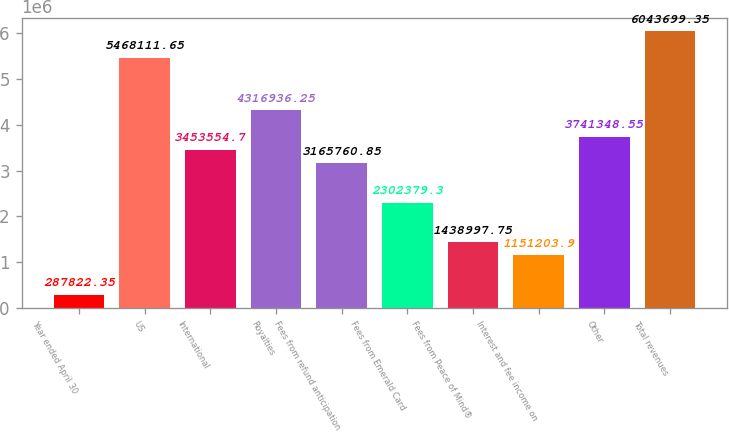Convert chart. <chart><loc_0><loc_0><loc_500><loc_500><bar_chart><fcel>Year ended April 30<fcel>US<fcel>International<fcel>Royalties<fcel>Fees from refund anticipation<fcel>Fees from Emerald Card<fcel>Fees from Peace of Mind®<fcel>Interest and fee income on<fcel>Other<fcel>Total revenues<nl><fcel>287822<fcel>5.46811e+06<fcel>3.45355e+06<fcel>4.31694e+06<fcel>3.16576e+06<fcel>2.30238e+06<fcel>1.439e+06<fcel>1.1512e+06<fcel>3.74135e+06<fcel>6.0437e+06<nl></chart> 